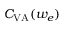Convert formula to latex. <formula><loc_0><loc_0><loc_500><loc_500>C _ { V A } ( w _ { e } )</formula> 